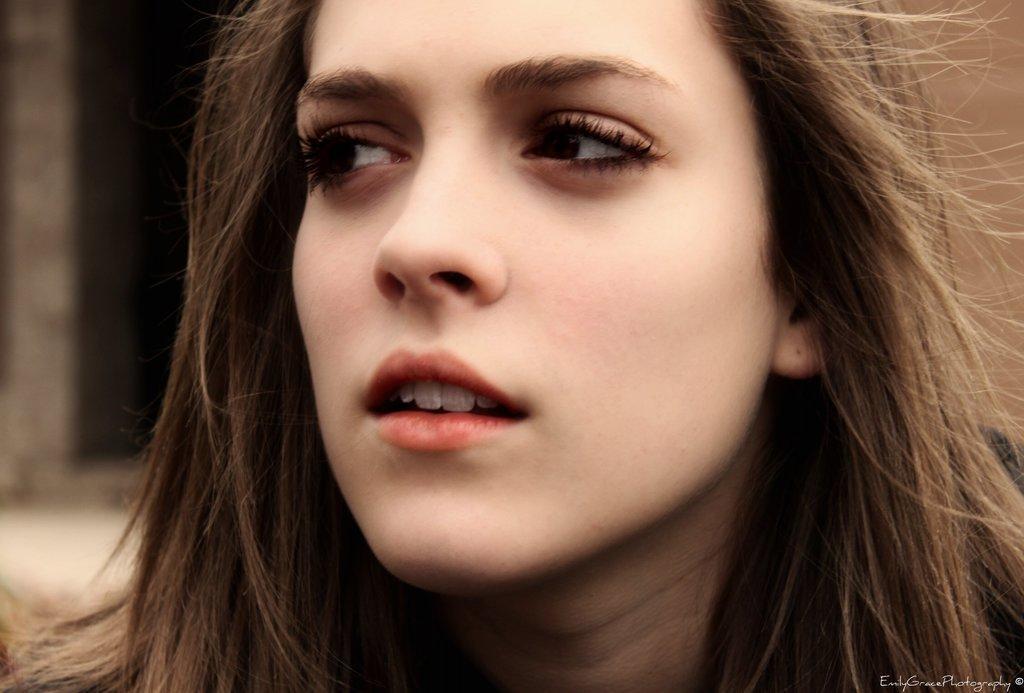Could you give a brief overview of what you see in this image? In the foreground of this picture, there is a woman's face with loose hair and the background is blurred. 